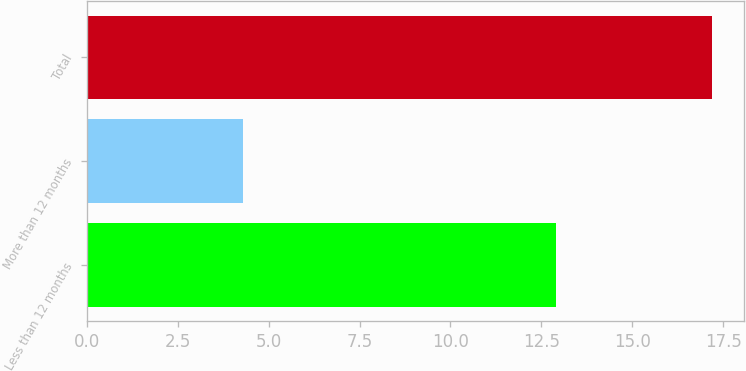<chart> <loc_0><loc_0><loc_500><loc_500><bar_chart><fcel>Less than 12 months<fcel>More than 12 months<fcel>Total<nl><fcel>12.9<fcel>4.3<fcel>17.2<nl></chart> 